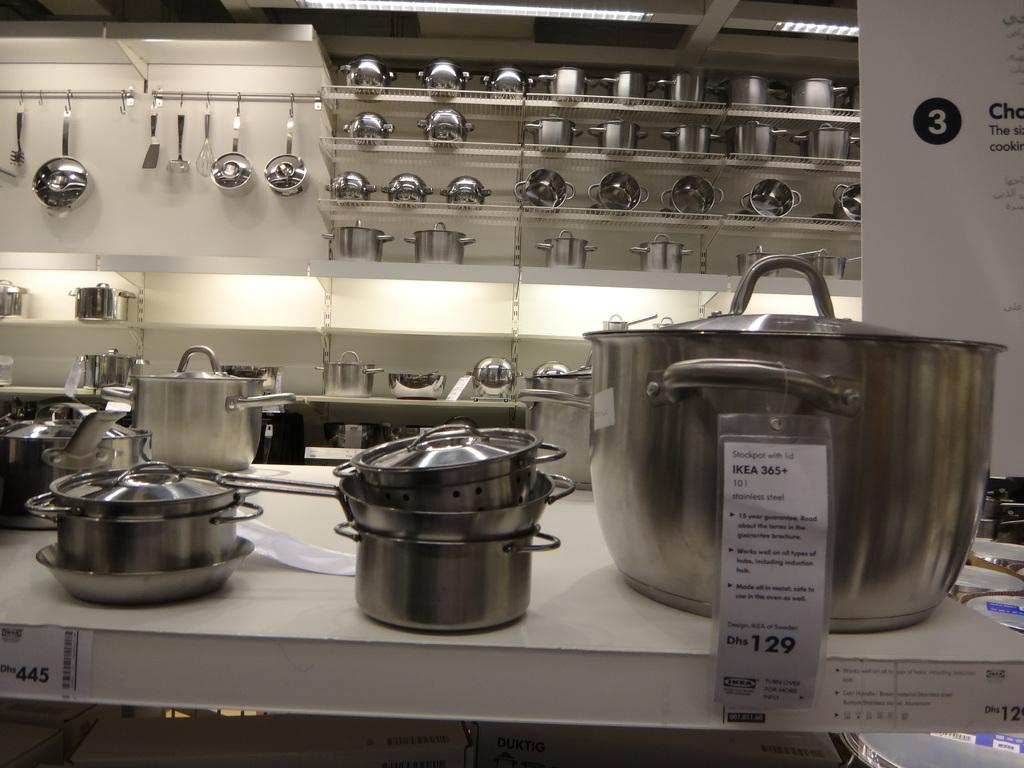<image>
Share a concise interpretation of the image provided. The shelves are carrying IKEA kitchen pots and pans, including a stainless steel stockpot with lid saying Dhs 129 on the sign. 